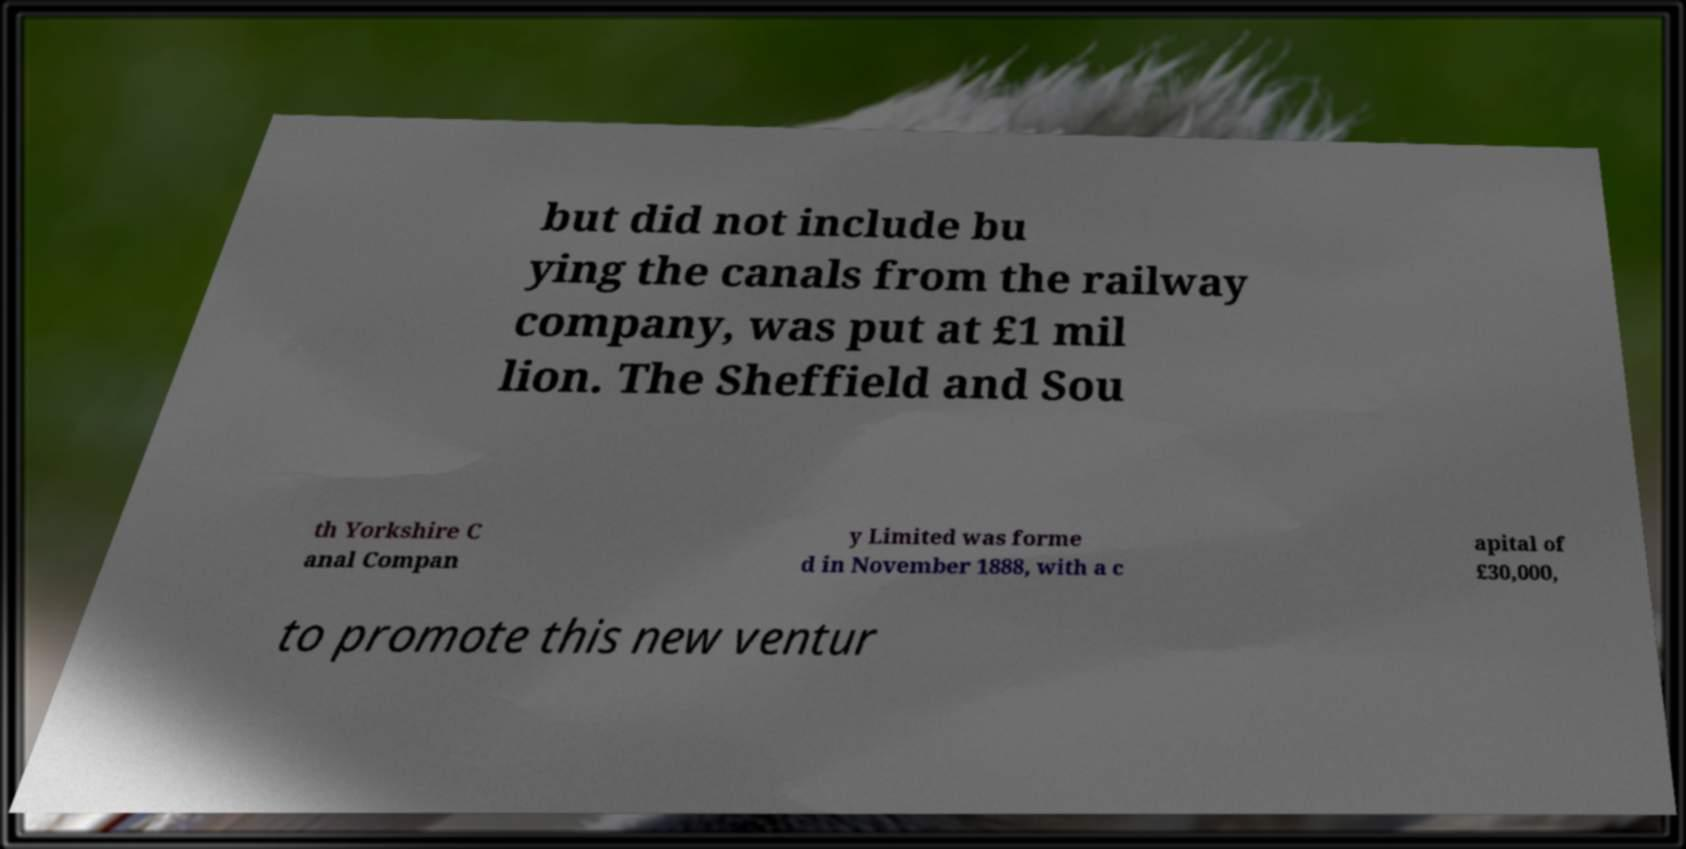Could you assist in decoding the text presented in this image and type it out clearly? but did not include bu ying the canals from the railway company, was put at £1 mil lion. The Sheffield and Sou th Yorkshire C anal Compan y Limited was forme d in November 1888, with a c apital of £30,000, to promote this new ventur 